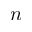<formula> <loc_0><loc_0><loc_500><loc_500>n</formula> 